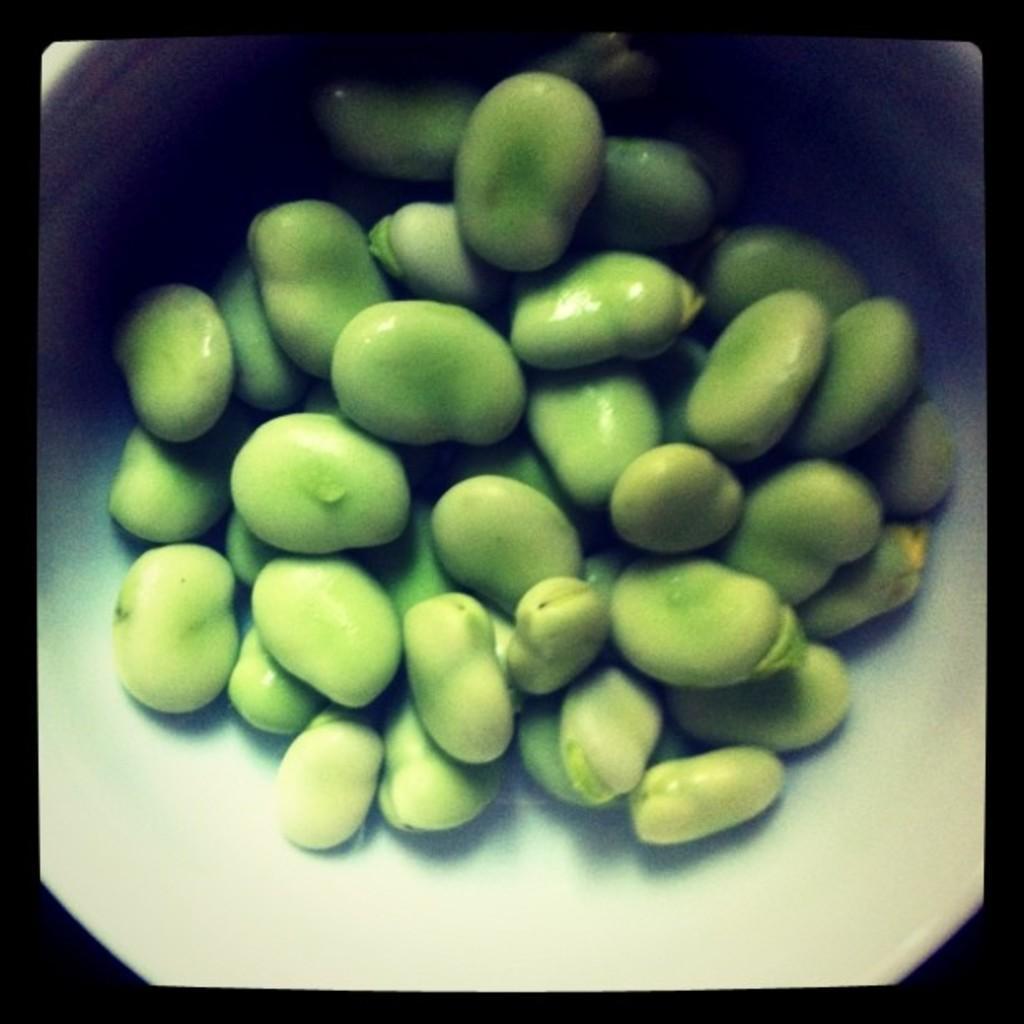Please provide a concise description of this image. In the image we can see there are seeds kept in the bowl. 